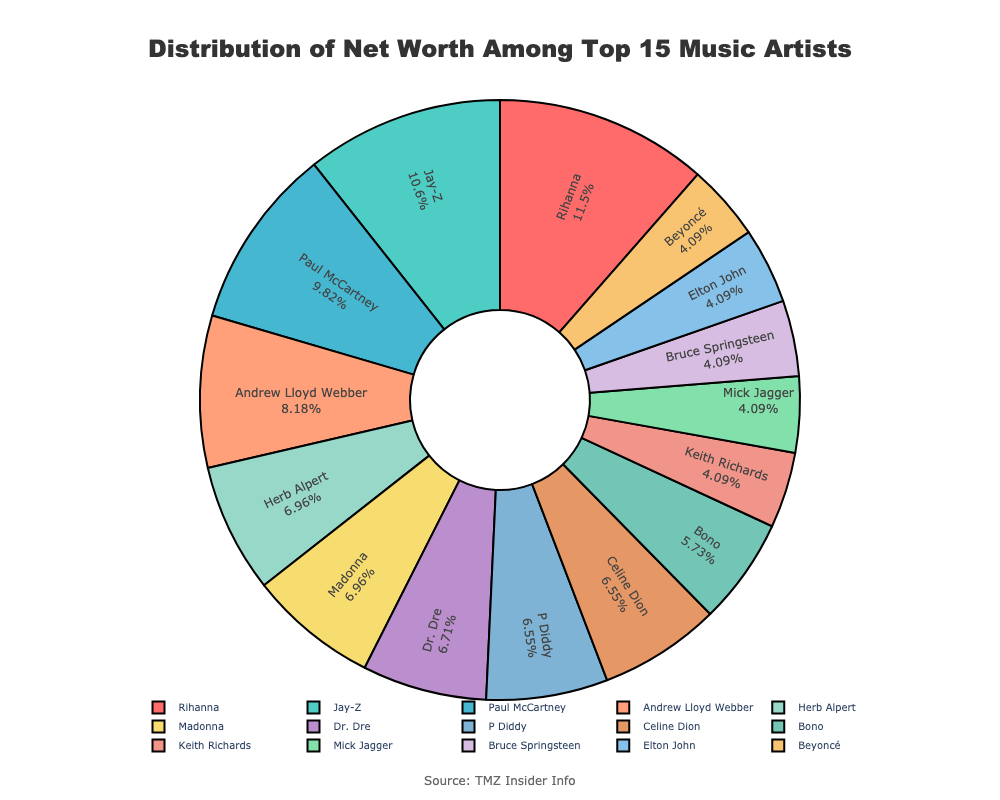what is the percentage share of Rihanna's net worth out of the total top 15 artists? To find Rihanna's percentage, divide her net worth by the sum of the net worth of the top 15 artists, and then multiply by 100. First, sum up the top 15 net worths (1400 + 1300 + 1200 + 1000 + 850 + 850 + 820 + 800 + 800 + 700 + 500 + 500 + 500 + 500 + 450 = 12170). Then compute the percentage: (1400 / 12170) * 100 ≈ 11.5%
Answer: 11.5% How much higher is Jay-Z's net worth compared to Celine Dion's net worth? To find the difference between Jay-Z's and Celine Dion's net worth, subtract Celine Dion's net worth from Jay-Z's: 1300 - 800 = 500 million USD.
Answer: 500 million USD Which artist has a higher net worth, Madonna or Dr. Dre? From the pie chart, compare the two values indicated for Madonna's and Dr. Dre's net worth. Both are listed at the same value: 850 million USD.
Answer: They have the same net worth What's the combined net worth of the artists who have a net worth of 800 million USD in the top 15? The artists with an 800 million USD net worth in the top 15 are P Diddy and Celine Dion. Their combined net worth is: 800 + 800 = 1600 million USD.
Answer: 1600 million USD What is the approximate percentage difference between Rihanna's and Paul McCartney's net worth? To find the percentage difference, subtract Paul's net worth from Rihanna's and then divide by Paul's net worth, multiplying by 100: ((1400 - 1200) / 1200) * 100 = (200 / 1200) * 100 ≈ 16.67%.
Answer: 16.67% Among the top 15 artists, how many have a net worth less than 1000 million USD? To answer this, count the artists in the top 15 with a net worth under 1000 million USD, which include those from Herb Alpert (850 million) to Dolly Parton (450 million), amounting to 10 artists.
Answer: 10 Which artist has the smallest share of the net worth in the chart? According to the pie chart and the provided data for the top 15, the artist with the smallest share is Dolly Parton with a net worth of 450 million USD.
Answer: Dolly Parton Whose net worth is visually represented by a green color on the pie chart? Match the color green to the corresponding segment on the provided pie chart. According to the colors used, Beyoncé's portion is represented in green.
Answer: Beyoncé How does the combined net worth of Jay-Z and Paul McCartney compare to Rihanna's net worth? Sum Jay-Z's and Paul McCartney's net worth: 1300 + 1200 = 2500 million USD. Compare this to Rihanna’s net worth of 1400 million USD. Since 2500 > 1400, their combined net worth is higher.
Answer: Jay-Z and Paul McCartney combined have a higher net worth Which artist listed in the top 15 has a net worth exactly equal to 850 million USD? By referring to the pie chart, the artists with net worth exactly equal to 850 million USD are Herb Alpert and Madonna.
Answer: Herb Alpert and Madonna 